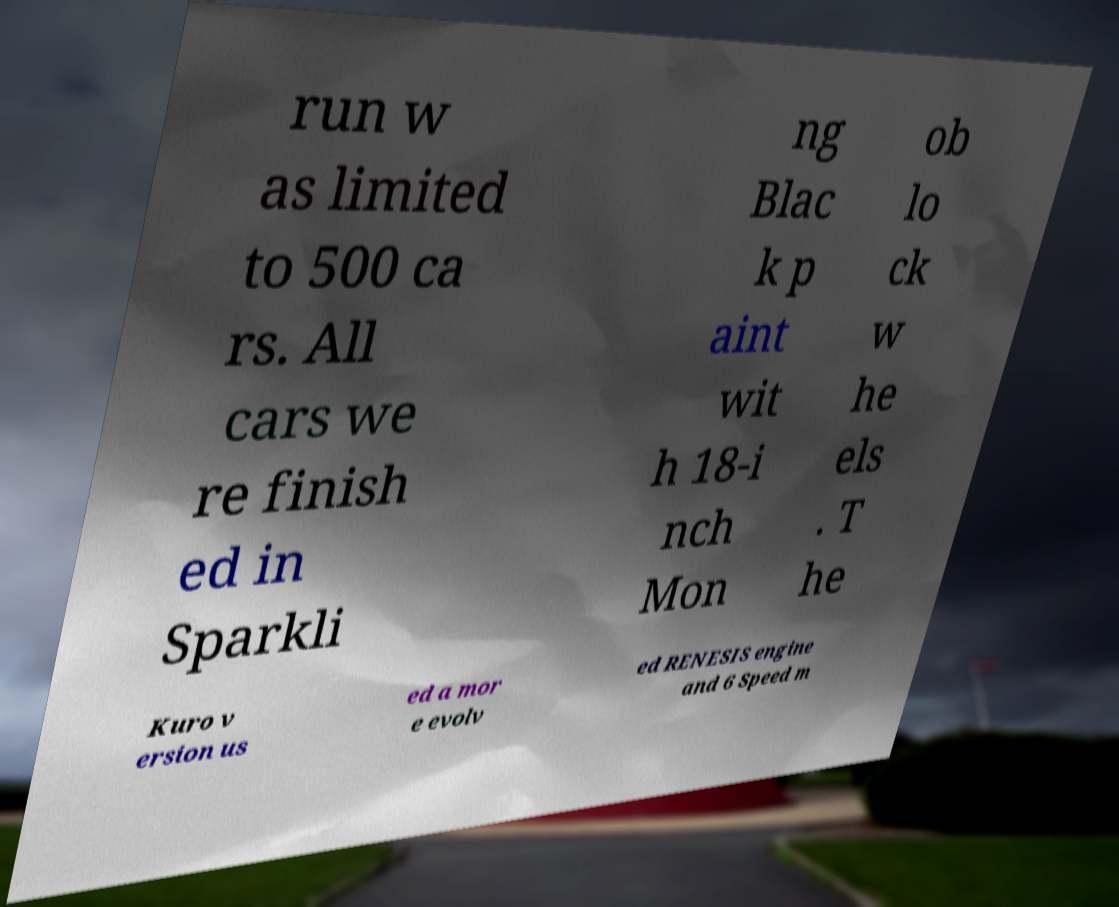For documentation purposes, I need the text within this image transcribed. Could you provide that? run w as limited to 500 ca rs. All cars we re finish ed in Sparkli ng Blac k p aint wit h 18-i nch Mon ob lo ck w he els . T he Kuro v ersion us ed a mor e evolv ed RENESIS engine and 6 Speed m 